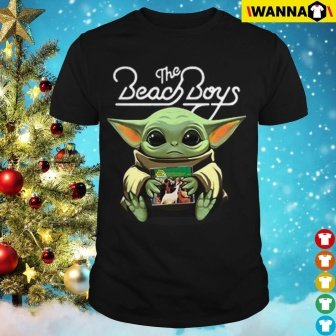What do you see happening in this image? The image prominently features a black t-shirt displayed against the festive backdrop of a lavishly decorated Christmas tree. The t-shirt bears an intriguing design: a whimsical green creature with large expressive ears holds a potted plant. This creature, reminiscent of popular sci-fi characters, is depicted wearing a white shirt that proudly displays 'The Beach Boys' in an eye-catching black cursive font. The juxtaposition of this unique, possibly collectible apparel with the traditional and richly adorned Christmas tree hints at a playful, festive gift, blending pop culture and holiday cheer. This setting not only showcases a potential holiday gift but also reflects a fusion of different celebratory elements, appealing to enthusiasts of unique clothing and festive decor alike. 